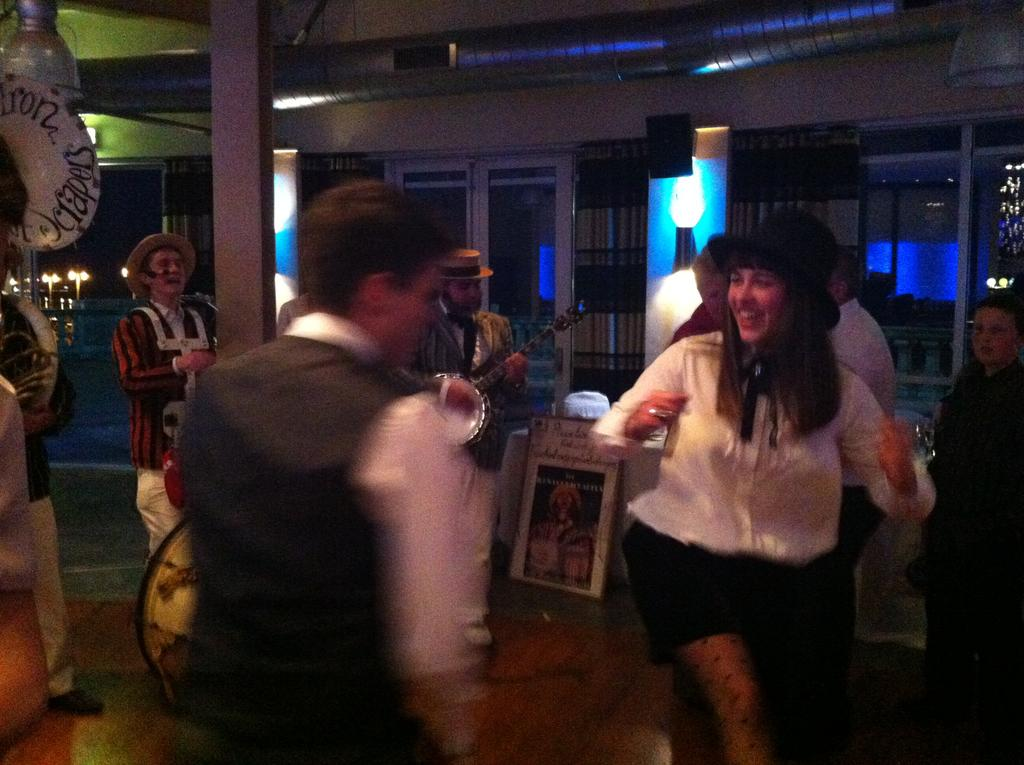What are the people in the image doing? There are people dancing, standing, and playing musical instruments in the image. Can you describe the musical aspect of the image? Yes, there are people playing musical instruments in the image. What is attached to the wall in the image? There is a speaker on the wall in the image. Is there any text visible in the image? Yes, there is a board with text in the image. What type of jewel is being worn by the lead singer in the image? There is no lead singer or jewel mentioned in the image; it features people dancing, standing, and playing musical instruments, along with a speaker on the wall and a board with text. 